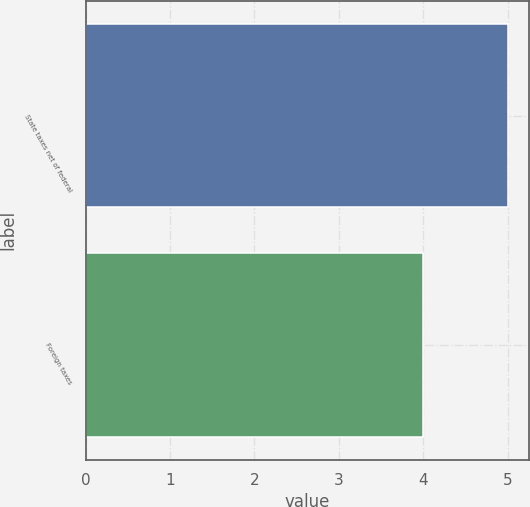<chart> <loc_0><loc_0><loc_500><loc_500><bar_chart><fcel>State taxes net of federal<fcel>Foreign taxes<nl><fcel>5<fcel>4<nl></chart> 